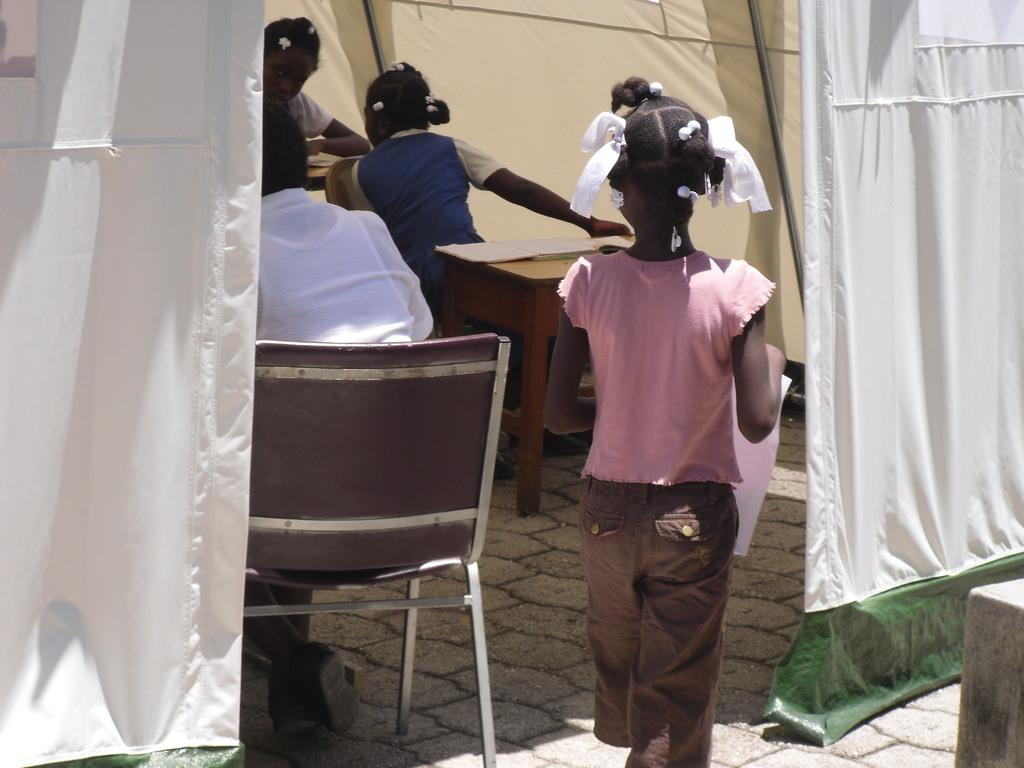What is the girl in the image doing? The girl is standing in the image and holding a paper in her hand. How many other girls are present in the image? There are other girls in the image, but the exact number is not specified. What piece of furniture can be seen in the image? There is a table and a chair in the image. Who is sitting on the chair in the image? There is a person sitting on the chair in the image. What type of wind can be seen blowing through the image? There is no wind present in the image; it is a still image. 